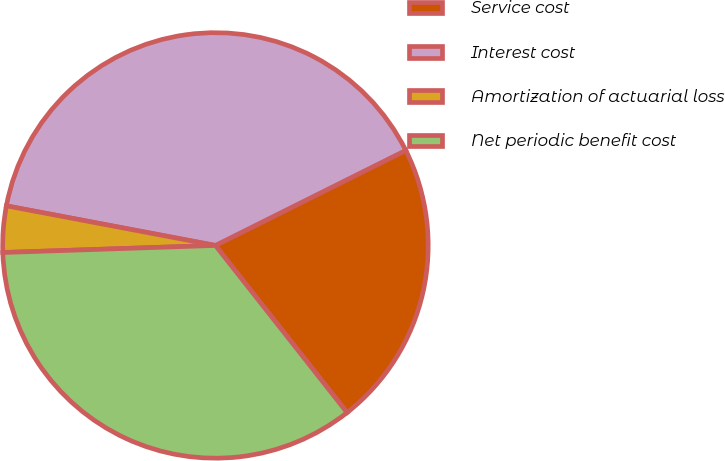Convert chart. <chart><loc_0><loc_0><loc_500><loc_500><pie_chart><fcel>Service cost<fcel>Interest cost<fcel>Amortization of actuarial loss<fcel>Net periodic benefit cost<nl><fcel>21.75%<fcel>39.65%<fcel>3.51%<fcel>35.09%<nl></chart> 